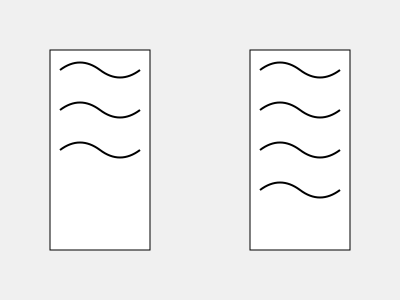Analyze the two shoe print patterns shown above. What is the key difference between them that could be crucial in identifying the suspect? To solve this question, let's examine the shoe print patterns step by step:

1. Observe the general layout: Both prints show a similar pattern of curved lines.

2. Count the number of lines:
   - Left print: 3 curved lines
   - Right print: 4 curved lines

3. Analyze the spacing:
   - Both prints have consistent spacing between lines
   - The additional line in the right print is at the bottom

4. Consider the implications:
   - The additional line in the right print suggests a different shoe tread pattern
   - This difference could be crucial in distinguishing between suspects

5. Evaluate the forensic significance:
   - The number of tread lines is a key characteristic in shoe print analysis
   - A mismatch in the number of lines can quickly eliminate or implicate a suspect

Therefore, the key difference is the number of curved lines in the tread pattern, with the right print having one additional line compared to the left print.
Answer: Number of tread lines (4 vs. 3) 